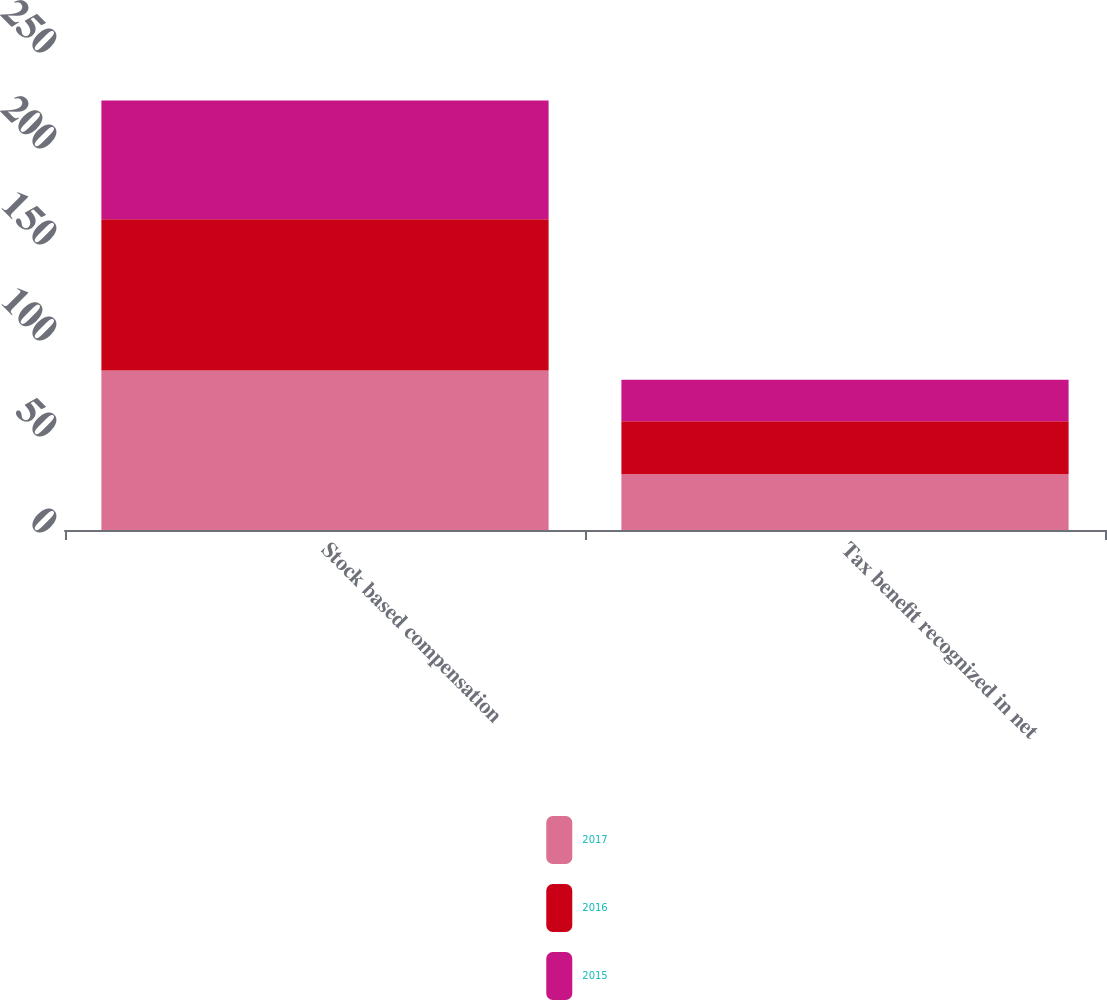Convert chart. <chart><loc_0><loc_0><loc_500><loc_500><stacked_bar_chart><ecel><fcel>Stock based compensation<fcel>Tax benefit recognized in net<nl><fcel>2017<fcel>83.1<fcel>29.1<nl><fcel>2016<fcel>78.8<fcel>27.6<nl><fcel>2015<fcel>61.8<fcel>21.6<nl></chart> 